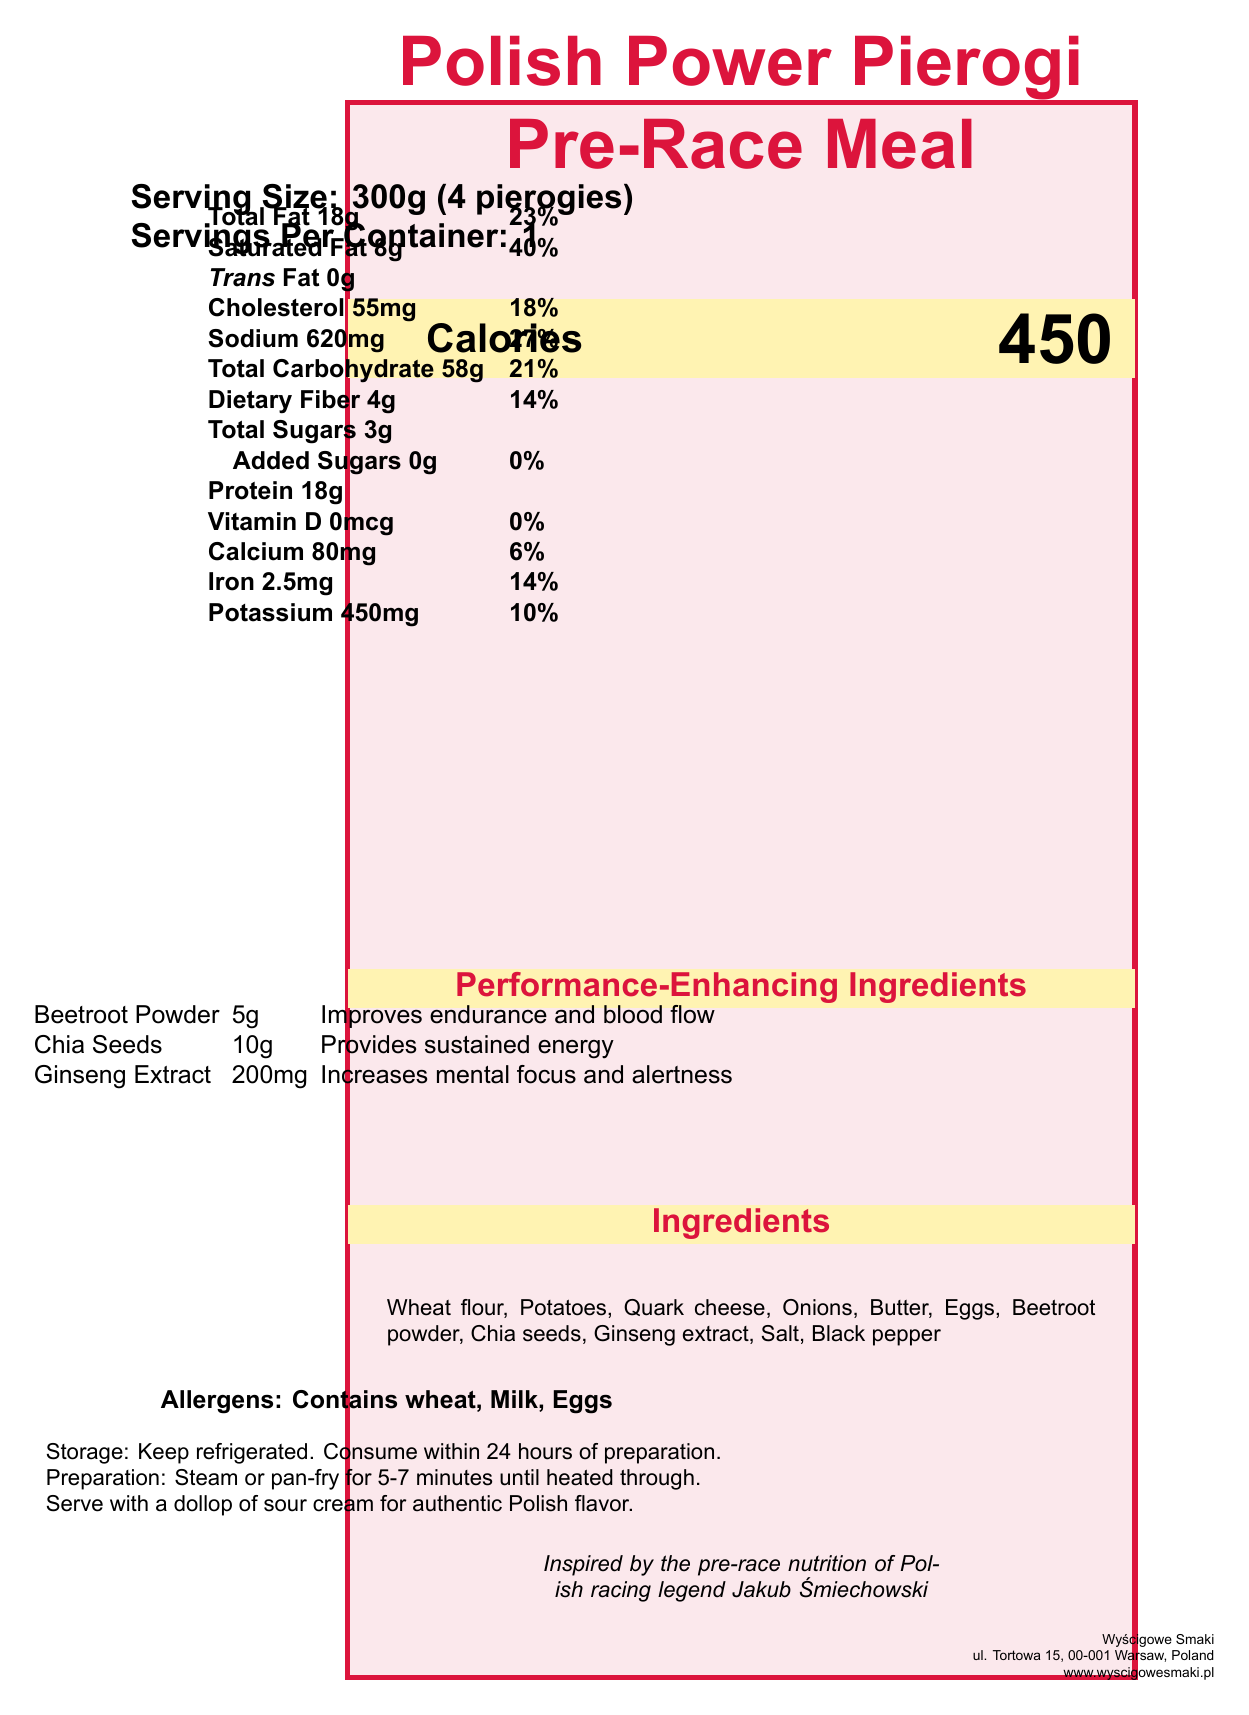what is the serving size for the Polish Power Pierogi Pre-Race Meal? The document specifies the serving size as 300g, which is equivalent to 4 pierogies.
Answer: 300g (4 pierogies) how many calories are there per serving? The document states that there are 450 calories per serving.
Answer: 450 what is the total fat content in a serving? According to the nutrient table, total fat per serving is 18g.
Answer: 18g what are the three performance-enhancing ingredients in the meal? The document lists these three ingredients under the "Performance-Enhancing Ingredients" section.
Answer: Beetroot Powder, Chia Seeds, Ginseng Extract how much cholesterol is in one serving? The nutrient table shows that the cholesterol content is 55mg per serving.
Answer: 55mg which ingredient in the meal is listed first? The "Ingredients" section lists wheat flour as the first ingredient.
Answer: Wheat flour how should the Polish Power Pierogi be prepared? A. Baked B. Boiled C. Fried D. Steamed or Pan-fried Under the "Preparation" section, the instructions are to steam or pan-fry the pierogies for 5-7 minutes.
Answer: D. Steamed or Pan-fried what is the main benefit of consuming beetroot powder included in the meal? The performance-enhancing ingredients section states that beetroot powder improves endurance and blood flow.
Answer: Improves endurance and blood flow how many grams of dietary fiber are in one serving? The document lists 4g of dietary fiber per serving.
Answer: 4g does the meal contain any added sugars? The document indicates that added sugars amount to 0g.
Answer: No is the meal suitable for someone with a wheat allergy? The allergen section clearly states that the meal contains wheat.
Answer: No what is the address of the manufacturer Wyścigowe Smaki? The manufacturer's information at the end of the document provides this address.
Answer: ul. Tortowa 15, 00-001 Warsaw, Poland which of these is Not an ingredient in the meal? I. Wheat flour II. Potatoes III. Tomatoes IV. Eggs The ingredients section lists wheat flour, potatoes, and eggs, but not tomatoes.
Answer: Tomatoes how much protein do you get per serving? The nutrient table lists 18g of protein per serving.
Answer: 18g how should the meal be stored? A. Keep frozen B. Keep at room temperature C. Keep refrigerated D. Keep in a dry place The storage instructions state that the meal should be kept refrigerated.
Answer: C. Keep refrigerated summarize the main idea of the document. The document aims to present a comprehensive nutritional profile and instructions for a traditional Polish pre-race meal designed to enhance performance.
Answer: The document provides detailed nutritional information for the Polish Power Pierogi Pre-Race Meal, including its serving size, calorie content, macro and micronutrients, ingredients, performance-enhancing ingredients, allergens, and preparation instructions. It emphasizes the meal's inspiration from Polish racing legend Jakub Śmiechowski. what benefits do chia seeds provide in this meal? The performance-enhancing ingredients section lists this benefit for chia seeds.
Answer: Provides sustained energy how many milligrams of calcium are there in one serving? The nutrient table lists 80mg of calcium per serving.
Answer: 80mg what percentage of the daily value of sodium does one serving provide? The nutrient table indicates that one serving provides 27% of the daily value for sodium.
Answer: 27% does the meal contain any Vitamin D? The nutrient table lists Vitamin D as 0mcg, which is 0% of the daily value.
Answer: No what kind of oil is used in the meal? The document does not specify the type of oil used in the meal preparation.
Answer: Not enough information 